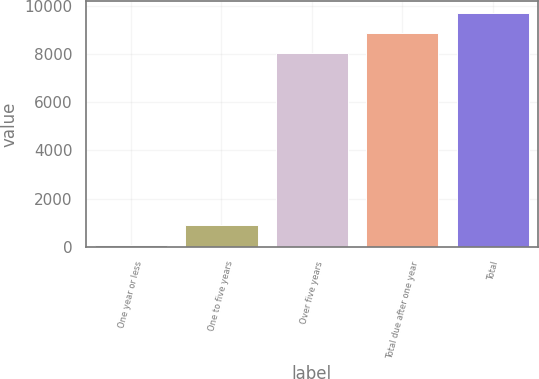<chart> <loc_0><loc_0><loc_500><loc_500><bar_chart><fcel>One year or less<fcel>One to five years<fcel>Over five years<fcel>Total due after one year<fcel>Total<nl><fcel>95.7<fcel>920.13<fcel>8055.9<fcel>8880.33<fcel>9704.76<nl></chart> 